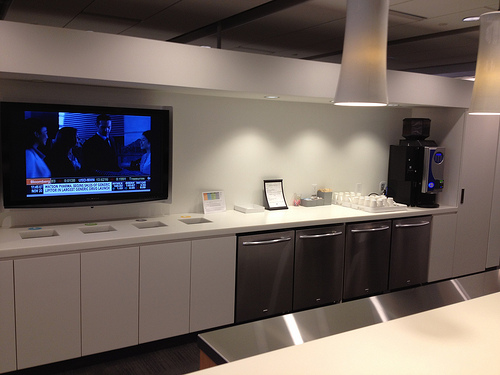Please provide the bounding box coordinate of the region this sentence describes: the silver counter top. The bounding box coordinates for the silver countertop are [0.4, 0.67, 1.0, 0.82]. 